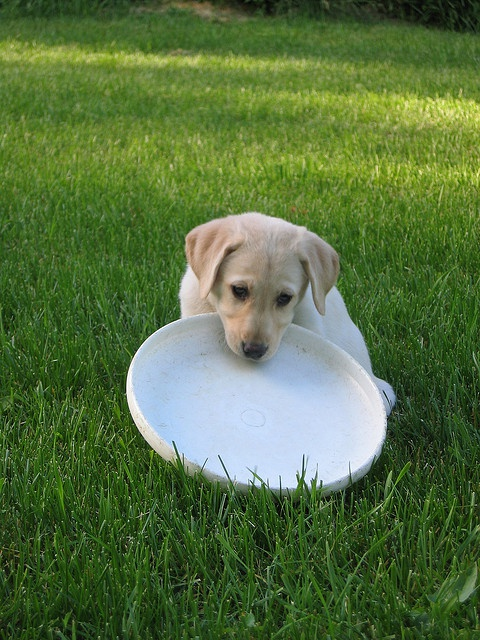Describe the objects in this image and their specific colors. I can see frisbee in darkgreen, lavender, lightblue, and darkgray tones and dog in darkgreen, darkgray, gray, and tan tones in this image. 